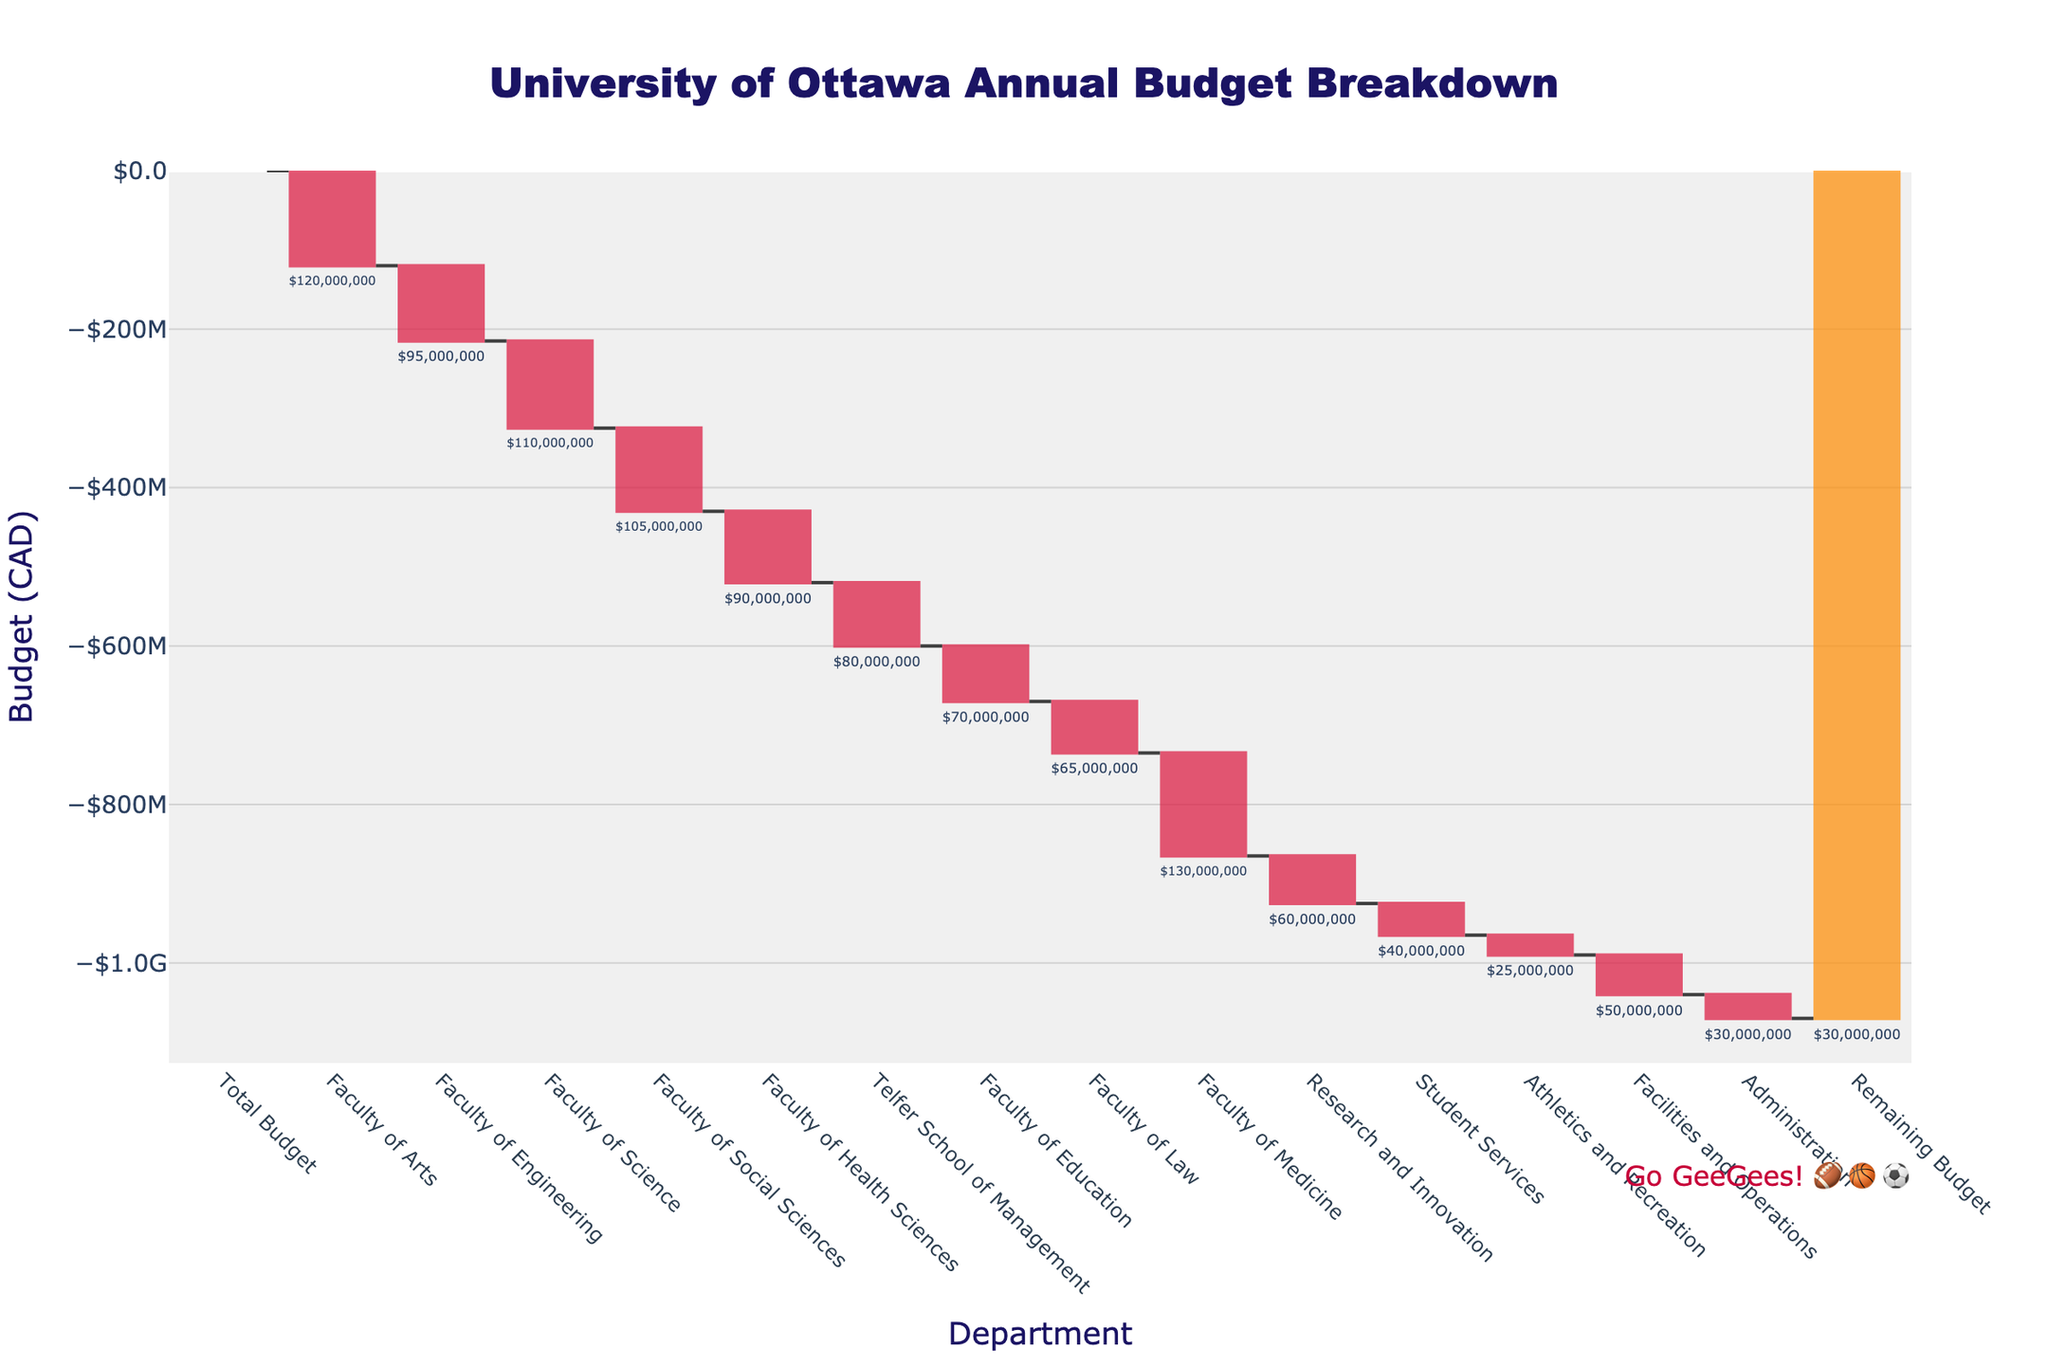What's the title of the figure? The title is usually displayed at the top of the chart. In this case, the title is "University of Ottawa Annual Budget Breakdown".
Answer: University of Ottawa Annual Budget Breakdown How many categories are displayed in the chart? To find the number of categories, count all the category names along the x-axis. There are 15 categories including the total budget and remaining budget.
Answer: 15 Which department has the largest budget allocation? Observe the largest downward bar representing a department with the maximum negative value. The Faculty of Medicine has the largest bar indicating a budget of -130,000,000 CAD.
Answer: Faculty of Medicine What is the remaining budget after all department allocations? The remaining budget is represented at the end of the waterfall chart. It is marked as "Remaining Budget" with a value of 30,000,000 CAD.
Answer: 30,000,000 CAD How much budget is allocated to the Faculty of Engineering? Find the bar labeled "Faculty of Engineering". The budget allocation is shown next to it as -95,000,000 CAD.
Answer: -95,000,000 CAD What's the combined budget of the Faculty of Health Sciences and the Telfer School of Management? Sum the values associated with both categories. The Faculty of Health Sciences has -90,000,000 CAD and the Telfer School of Management has -80,000,000 CAD, resulting in a sum of -170,000,000 CAD.
Answer: -170,000,000 CAD Which department’s budget is closest to that of the Faculty of Social Sciences? Compare the budget of other departments with -105,000,000 CAD allocated to the Faculty of Social Sciences. The Faculty of Engineering has a budget of -95,000,000 CAD which is closest.
Answer: Faculty of Engineering What is the total budget allocated across all departments excluding "Total Budget" and "Remaining Budget"? Sum up all department values: Faculty of Arts (-120,000,000) + Faculty of Engineering (-95,000,000) + Faculty of Science (-110,000,000) + Faculty of Social Sciences (-105,000,000) + Faculty of Health Sciences (-90,000,000) + Telfer School of Management (-80,000,000) + Faculty of Education (-70,000,000) + Faculty of Law (-65,000,000) + Faculty of Medicine (-130,000,000) + Research and Innovation (-60,000,000) + Student Services (-40,000,000) + Athletics and Recreation (-25,000,000) + Facilities and Operations (-50,000,000) + Administration (-30,000,000) = -1,070,000,000 CAD.
Answer: -1,070,000,000 CAD Which category has the smallest budget allocation? The smallest negative value or shortest bar on the chart belongs to Athletics and Recreation, at -25,000,000 CAD.
Answer: Athletics and Recreation 